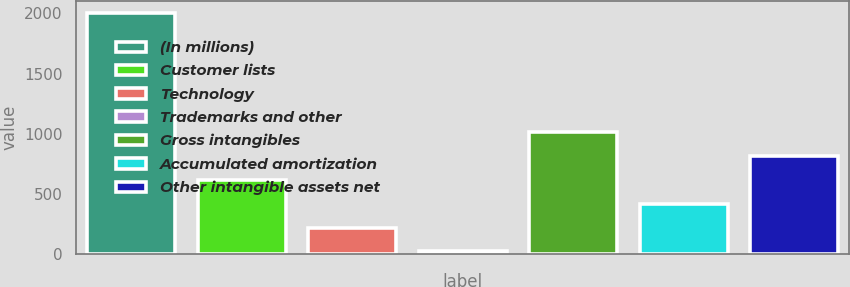<chart> <loc_0><loc_0><loc_500><loc_500><bar_chart><fcel>(In millions)<fcel>Customer lists<fcel>Technology<fcel>Trademarks and other<fcel>Gross intangibles<fcel>Accumulated amortization<fcel>Other intangible assets net<nl><fcel>2003<fcel>615.95<fcel>219.65<fcel>21.5<fcel>1012.25<fcel>417.8<fcel>814.1<nl></chart> 